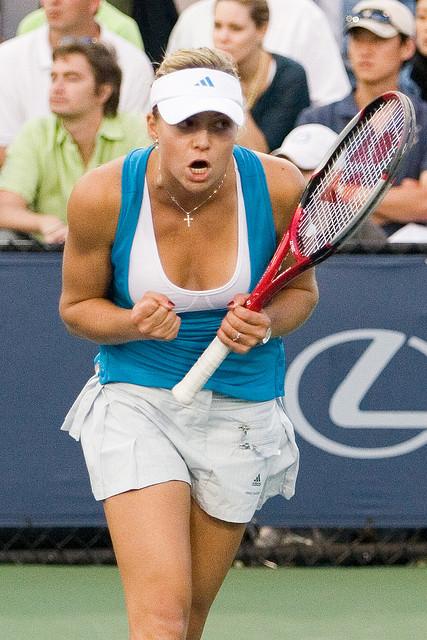Is she angry?
Write a very short answer. No. What is this person wearing on their head?
Keep it brief. Visor. What is she playing?
Keep it brief. Tennis. 